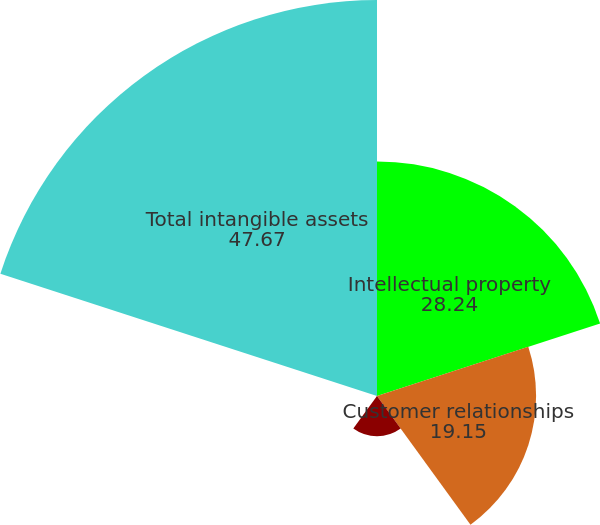Convert chart to OTSL. <chart><loc_0><loc_0><loc_500><loc_500><pie_chart><fcel>Intellectual property<fcel>Customer relationships<fcel>Tradename<fcel>Backlog<fcel>Total intangible assets<nl><fcel>28.24%<fcel>19.15%<fcel>4.85%<fcel>0.09%<fcel>47.67%<nl></chart> 